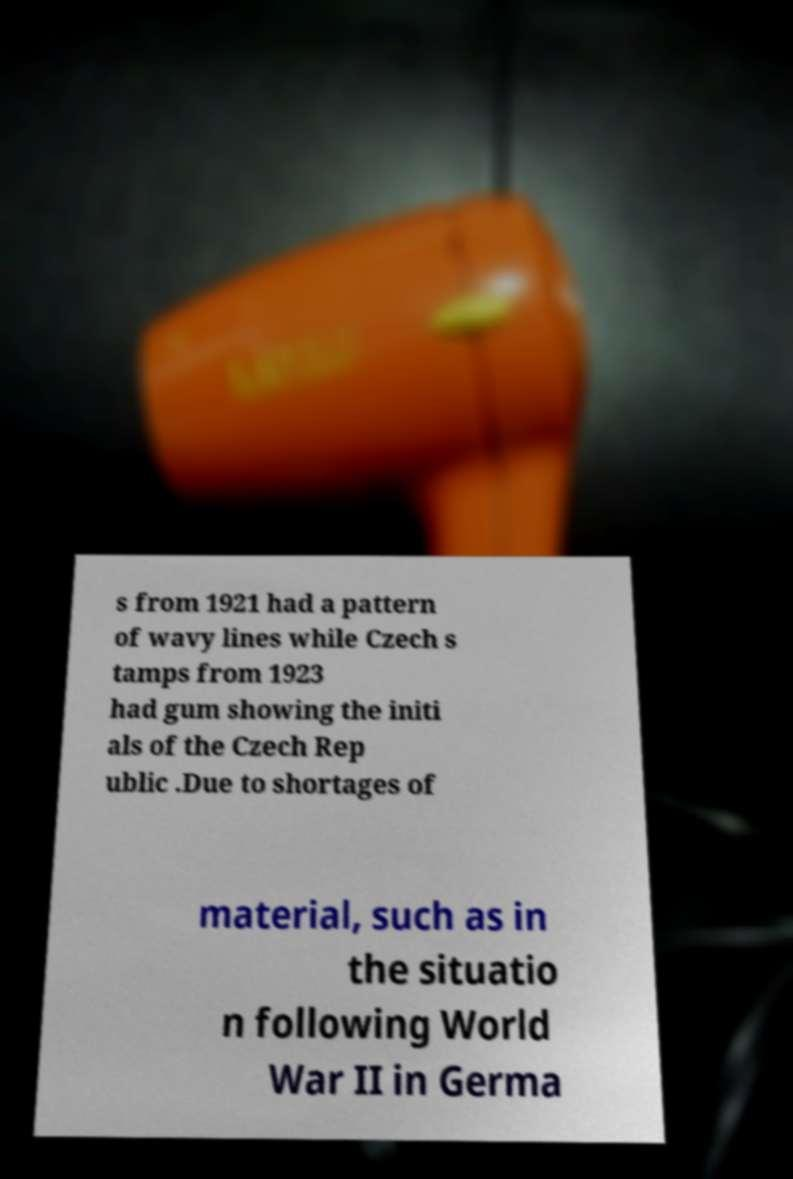Please read and relay the text visible in this image. What does it say? s from 1921 had a pattern of wavy lines while Czech s tamps from 1923 had gum showing the initi als of the Czech Rep ublic .Due to shortages of material, such as in the situatio n following World War II in Germa 